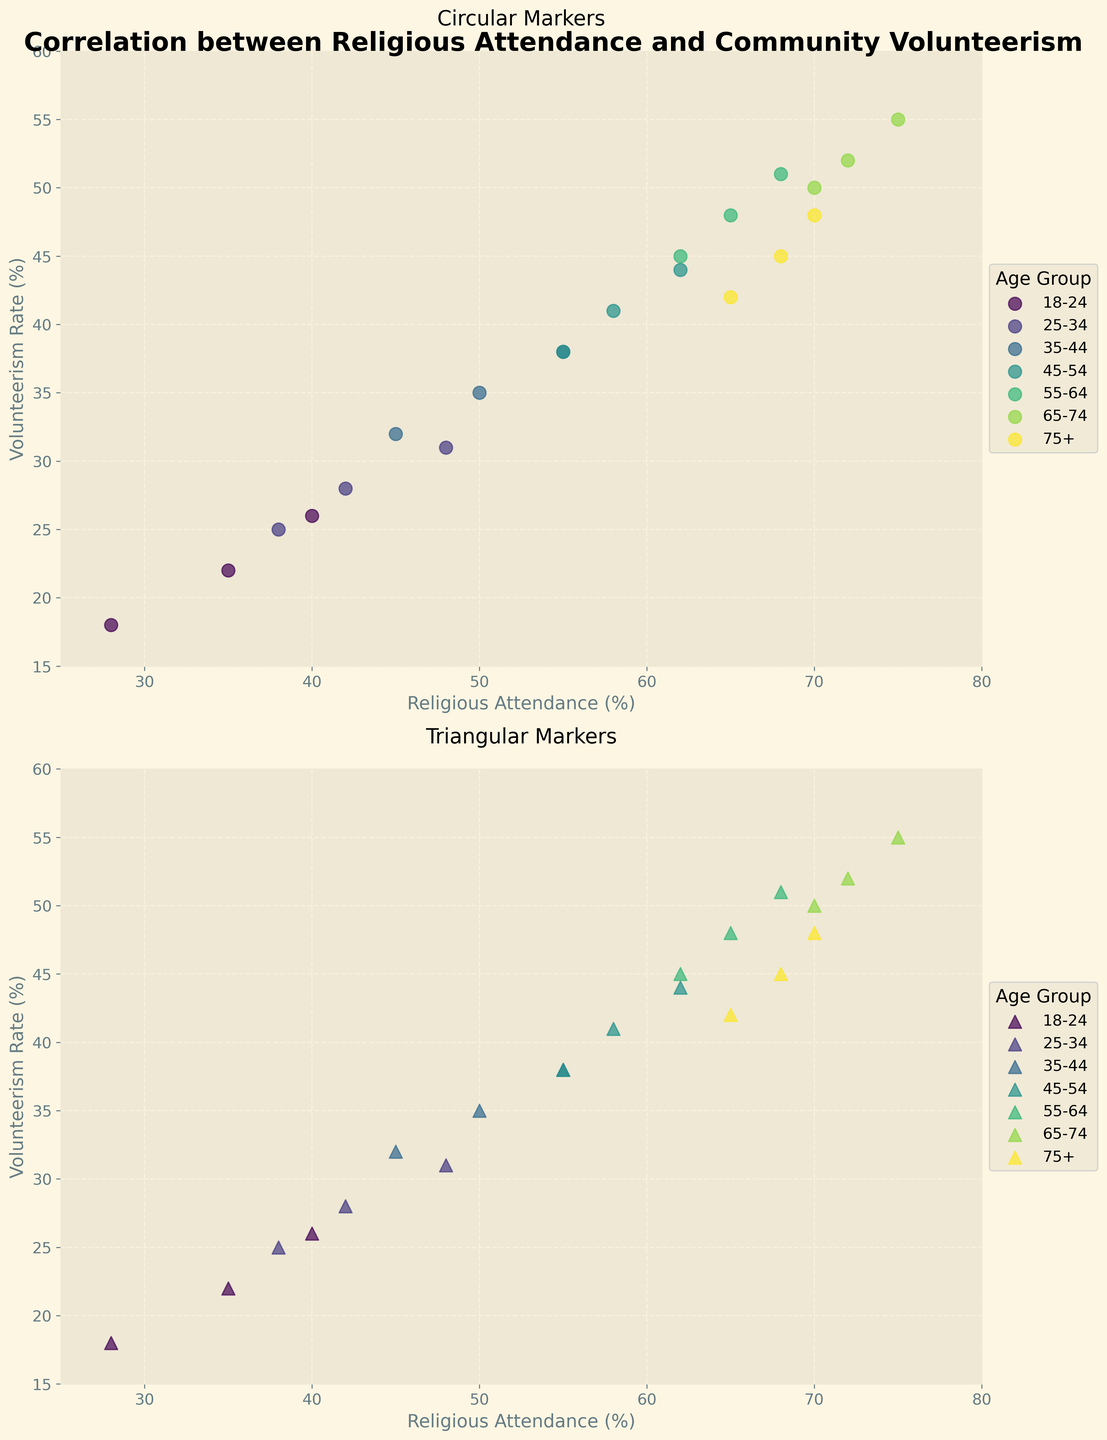What is the title of the figure? The main title can be found at the top of the figure, bold and prominent.
Answer: Correlation between Religious Attendance and Community Volunteerism What are the x-axis and y-axis labels in the subplot with circular markers? Looking at the first subplot with circular markers, the labels for the x-axis and y-axis can be found along the horizontal and vertical lines, respectively.
Answer: Religious Attendance (%) and Volunteerism Rate (%) Which age group has the highest volunteerism rate in the circular markers subplot? In the subplot with circular markers, locate the data points and identify the one with the highest y-value, which corresponds to the highest volunteerism rate.
Answer: 65-74 What’s the range of religious attendance percentages in the figure? Look at the x-axis limits set in both subplots; this provides the range of the religious attendance percentages.
Answer: 25 to 80 Which age group has the smallest range in volunteerism rates in the triangular markers subplot? In the triangular markers subplot, compare the ranges (difference between max and min) of volunteerism rates for each age group by noting the positions of their data points on the y-axis.
Answer: 75+ What’s the average volunteerism rate of the 55-64 age group in the circular markers subplot? Identify the relevant data points for the 55-64 age group in the circular markers subplot and calculate their average.
Answer: 48 Can you identify a positive correlation in both subplots? Observe the general trend in both subplots. If points trend upwards as the x-values increase, then there is a positive correlation.
Answer: Yes How do the patterns of the scatter plots change between different markers in subplots? Compare the distributions of data points in both subplots, noting any differences in spread, clustering, or alignment between the circular and triangular markers.
Answer: Similar patterns, but slightly different arrangements Which subplot shows a broader spread in the volunteerism rates for the 18-24 age group? Compare the vertical spread (on the y-axis) of data points for the 18-24 age group between the two subplots.
Answer: Circular markers Which age group shows a decrease in volunteerism rate in the triangular markers subplot? Look for data points in the triangular markers subplot where an age group’s volunteerism rate appears lower than for younger or older age groups.
Answer: 75+ 